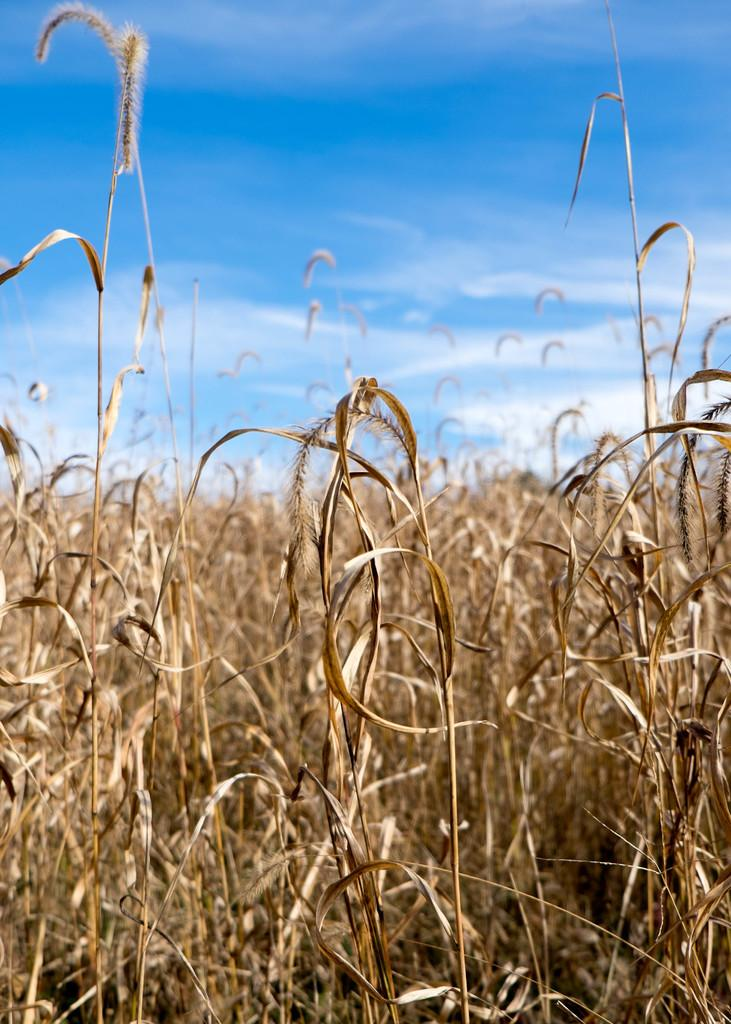What type of vegetation is present in the image? There is dry grass in the image. What can be seen in the background of the image? The sky is visible behind the grass in the image. What type of agreement is being discussed in the image? There is no indication of any agreement being discussed in the image; it features dry grass and the sky. What type of suit is visible in the image? There is no suit present in the image; it features dry grass and the sky. 